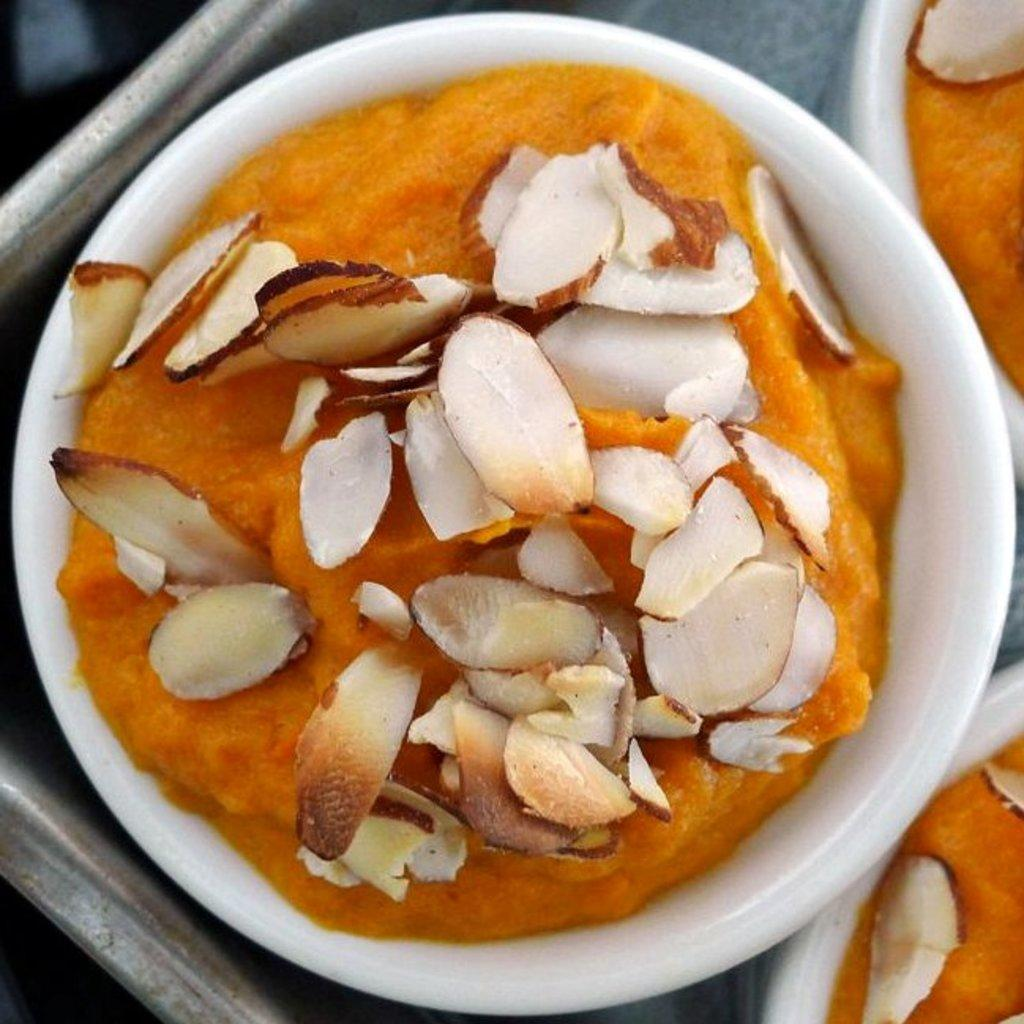What object can be seen in the image that might be used for carrying items? There is a tray in the image that can be used for carrying items. What type of natural element is present in the image? There is a tree in the image. What type of containers are visible in the image? There are bowls in the image. What type of food can be seen in the bowls? There is a sweet in the bowls. What type of wine is being served in the image? There is no wine present in the image. How does the tree say good-bye in the image? Trees do not have the ability to say good-bye, as they are inanimate objects. 